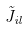Convert formula to latex. <formula><loc_0><loc_0><loc_500><loc_500>\tilde { J } _ { i l }</formula> 